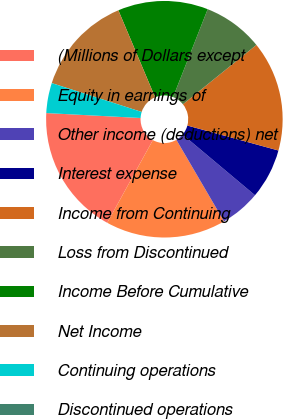Convert chart to OTSL. <chart><loc_0><loc_0><loc_500><loc_500><pie_chart><fcel>(Millions of Dollars except<fcel>Equity in earnings of<fcel>Other income (deductions) net<fcel>Interest expense<fcel>Income from Continuing<fcel>Loss from Discontinued<fcel>Income Before Cumulative<fcel>Net Income<fcel>Continuing operations<fcel>Discontinued operations<nl><fcel>17.81%<fcel>16.44%<fcel>5.48%<fcel>6.85%<fcel>15.07%<fcel>8.22%<fcel>12.33%<fcel>13.7%<fcel>4.11%<fcel>0.0%<nl></chart> 